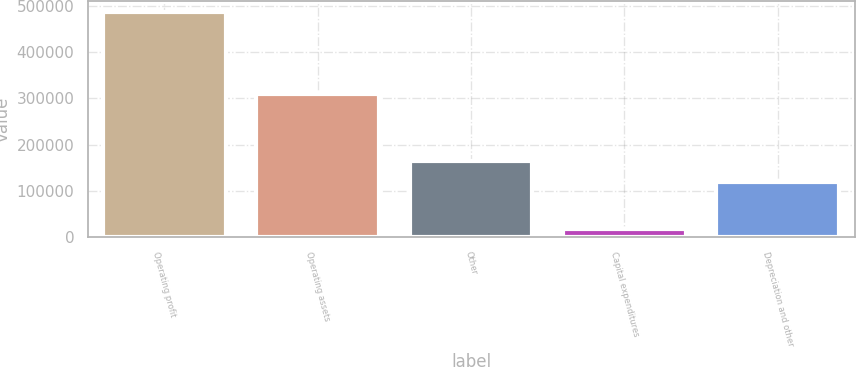<chart> <loc_0><loc_0><loc_500><loc_500><bar_chart><fcel>Operating profit<fcel>Operating assets<fcel>Other<fcel>Capital expenditures<fcel>Depreciation and other<nl><fcel>486575<fcel>309235<fcel>165421<fcel>18791<fcel>118643<nl></chart> 